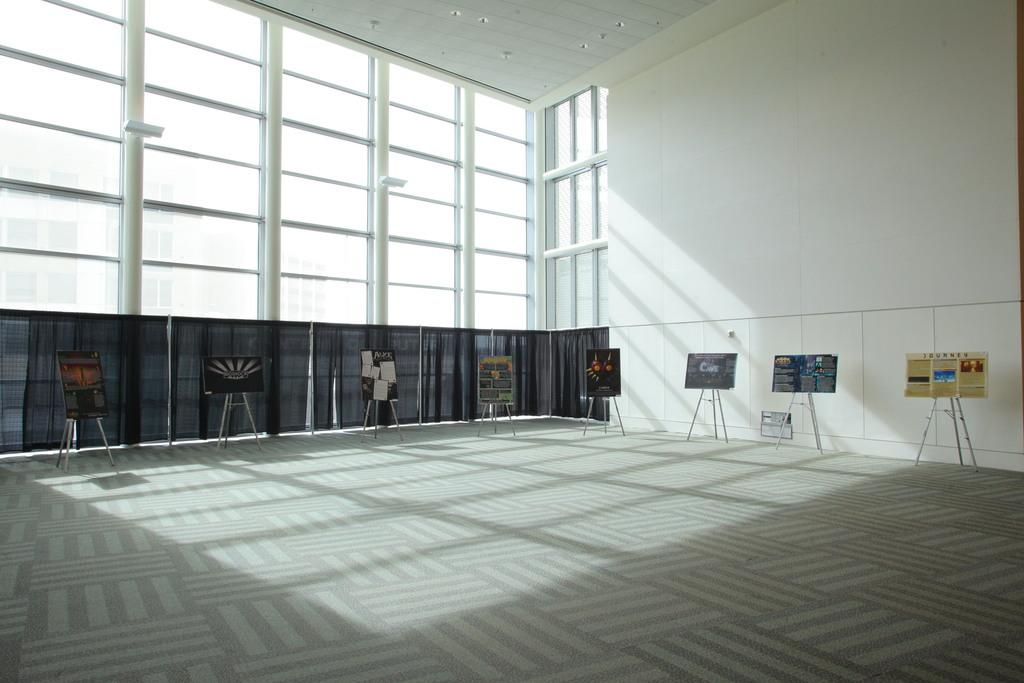What type of space is depicted in the image? The image shows an inner view of a room. What type of window treatment is present in the room? There are curtains in the room. What can be found on the boards in the room? The boards in the room have advertisements and paintings attached. Can you tell me how many horses are visible in the image? There are no horses present in the image. What type of war is being depicted in the painting on the board? There is no painting of a war present in the image; the boards have advertisements and paintings, but none depict a war. 